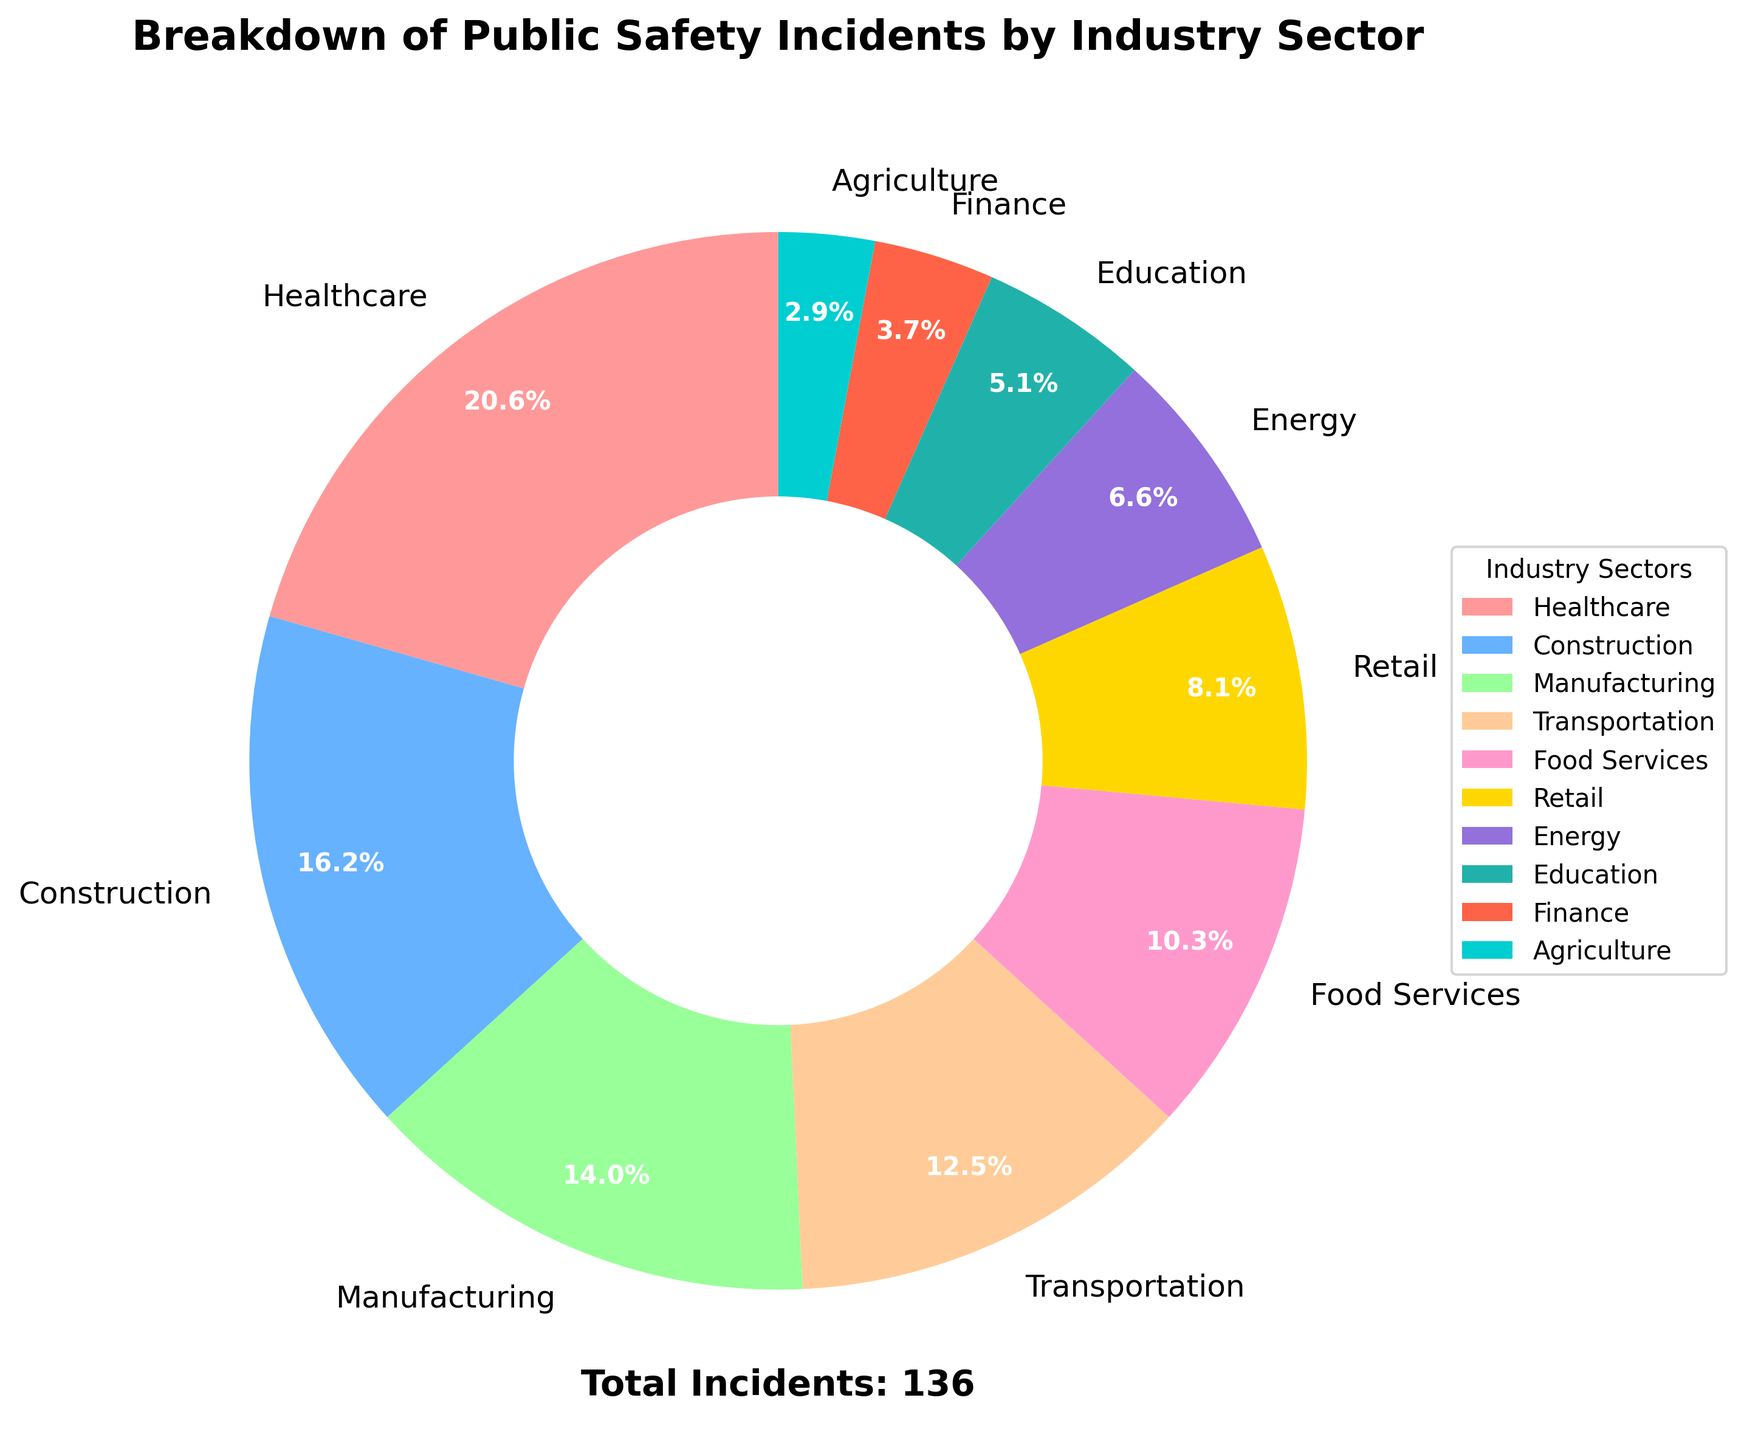What industry sector has the highest number of public safety incidents? The healthcare sector has the highest number of incidents, as represented by the largest slice of the pie chart with the label showing 28 incidents.
Answer: Healthcare Which two sectors combined have the same number of incidents as the Healthcare sector? The sectors of Construction and Manufacturing combined have 41 incidents (22 from Construction and 19 from Manufacturing), which is 13 incidents more than Healthcare. Therefore, no two sectors combined have the same exact number of incidents as Healthcare. However, Transport and Food Services combined have 31 incidents (17 from Transportation and 14 from Food Services), which is closer but still not exactly equal to 28. No exact match.
Answer: None What percentage of incidents are accounted for by the Transportation sector? The pie chart section for Transportation is labeled with 17 incidents, which represents a percentage calculated as (17 / 136) * 100 = 12.5%.
Answer: 12.5% Are there more incidents in the Manufacturing sector or Retail sector? The Manufacturing sector has 19 incidents while the Retail sector has 11 incidents, as shown by their respective sections of the pie chart.
Answer: Manufacturing How many total incidents occurred in the sectors with fewer than 10 incidents? The sectors with fewer than 10 incidents are Energy (9), Education (7), Finance (5), and Agriculture (4). Summing these gives 9 + 7 + 5 + 4 = 25 incidents.
Answer: 25 What is the combined percentage of incidents for the Construction and Food Services sectors? Construction has 22 incidents and Food Services has 14 incidents. The total number of incidents is 136. The combined percentage is ((22 + 14) / 136) * 100 = 26.5%.
Answer: 26.5% Which sector accounts for the smallest percentage of incidents, and what is that percentage? The Agriculture sector accounts for the smallest percentage of incidents with 4 incidents out of 136 total, which is calculated as (4 / 136) * 100 = 2.9%.
Answer: Agriculture, 2.9% What is the difference in the number of incidents between the Healthcare and Finance sectors? The Healthcare sector has 28 incidents and the Finance sector has 5 incidents. The difference is 28 - 5 = 23 incidents.
Answer: 23 What sector is represented by the light blue color in the pie chart? The pie chart uses different colors for each sector. According to the plotted colors, the light blue color represents the Construction sector.
Answer: Construction How many incidents do the top three sectors collectively have? The top three sectors by number of incidents are Healthcare (28), Construction (22), and Manufacturing (19). Their total is 28 + 22 + 19 = 69 incidents.
Answer: 69 